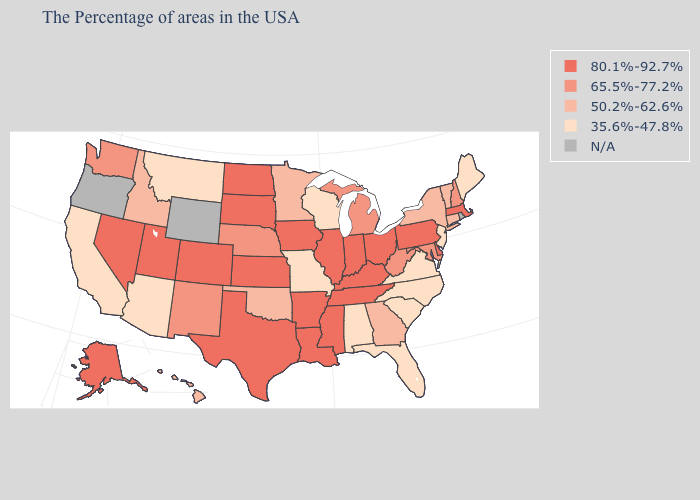Name the states that have a value in the range 65.5%-77.2%?
Give a very brief answer. New Hampshire, Maryland, West Virginia, Michigan, Nebraska, New Mexico, Washington. Name the states that have a value in the range 35.6%-47.8%?
Quick response, please. Maine, New Jersey, Virginia, North Carolina, South Carolina, Florida, Alabama, Wisconsin, Missouri, Montana, Arizona, California. What is the lowest value in the USA?
Write a very short answer. 35.6%-47.8%. What is the highest value in the USA?
Concise answer only. 80.1%-92.7%. Name the states that have a value in the range 50.2%-62.6%?
Write a very short answer. Vermont, Connecticut, New York, Georgia, Minnesota, Oklahoma, Idaho, Hawaii. Name the states that have a value in the range N/A?
Concise answer only. Rhode Island, Wyoming, Oregon. How many symbols are there in the legend?
Short answer required. 5. Which states have the lowest value in the MidWest?
Short answer required. Wisconsin, Missouri. What is the lowest value in the West?
Be succinct. 35.6%-47.8%. Does the map have missing data?
Answer briefly. Yes. Among the states that border Connecticut , does Massachusetts have the highest value?
Write a very short answer. Yes. How many symbols are there in the legend?
Quick response, please. 5. What is the highest value in the South ?
Write a very short answer. 80.1%-92.7%. Does Louisiana have the lowest value in the USA?
Concise answer only. No. What is the highest value in the USA?
Keep it brief. 80.1%-92.7%. 